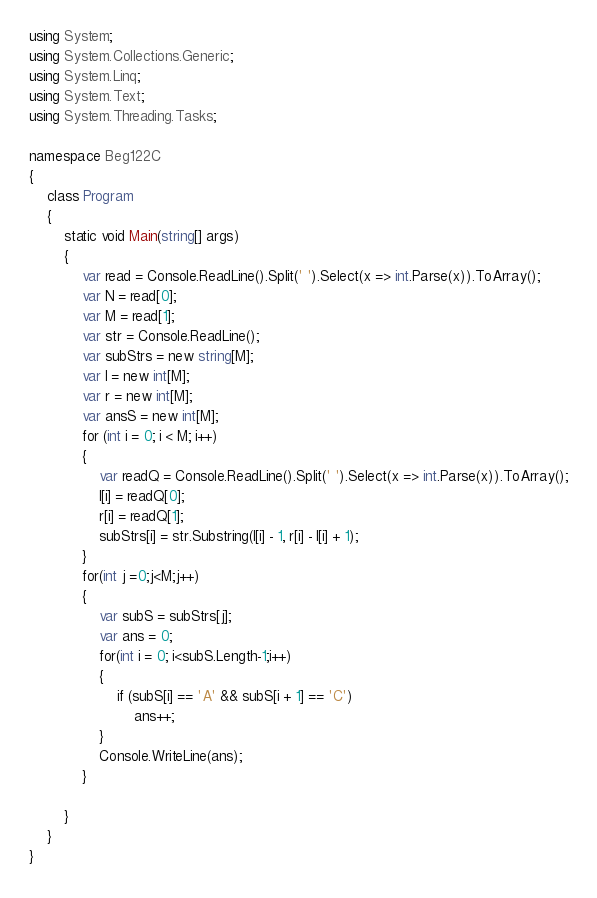<code> <loc_0><loc_0><loc_500><loc_500><_C#_>using System;
using System.Collections.Generic;
using System.Linq;
using System.Text;
using System.Threading.Tasks;

namespace Beg122C
{
    class Program
    {
        static void Main(string[] args)
        {
            var read = Console.ReadLine().Split(' ').Select(x => int.Parse(x)).ToArray();
            var N = read[0];
            var M = read[1];
            var str = Console.ReadLine();
            var subStrs = new string[M];
            var l = new int[M];
            var r = new int[M];
            var ansS = new int[M];
            for (int i = 0; i < M; i++)
            {
                var readQ = Console.ReadLine().Split(' ').Select(x => int.Parse(x)).ToArray();
                l[i] = readQ[0];
                r[i] = readQ[1];
                subStrs[i] = str.Substring(l[i] - 1, r[i] - l[i] + 1);
            }
            for(int j =0;j<M;j++)
            {
                var subS = subStrs[j];
                var ans = 0;
                for(int i = 0; i<subS.Length-1;i++)
                {
                    if (subS[i] == 'A' && subS[i + 1] == 'C')
                        ans++;
                }
                Console.WriteLine(ans);
            }
            
        }
    }
}
</code> 